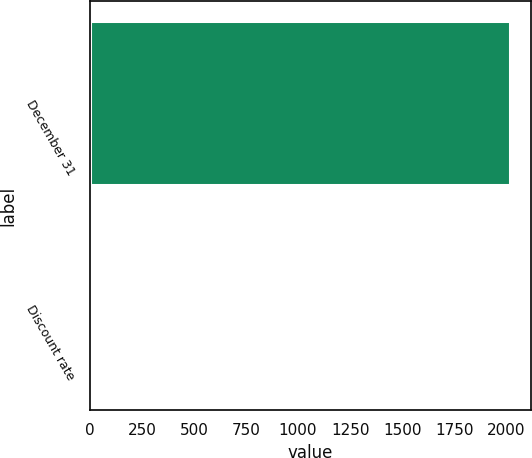<chart> <loc_0><loc_0><loc_500><loc_500><bar_chart><fcel>December 31<fcel>Discount rate<nl><fcel>2018<fcel>4<nl></chart> 